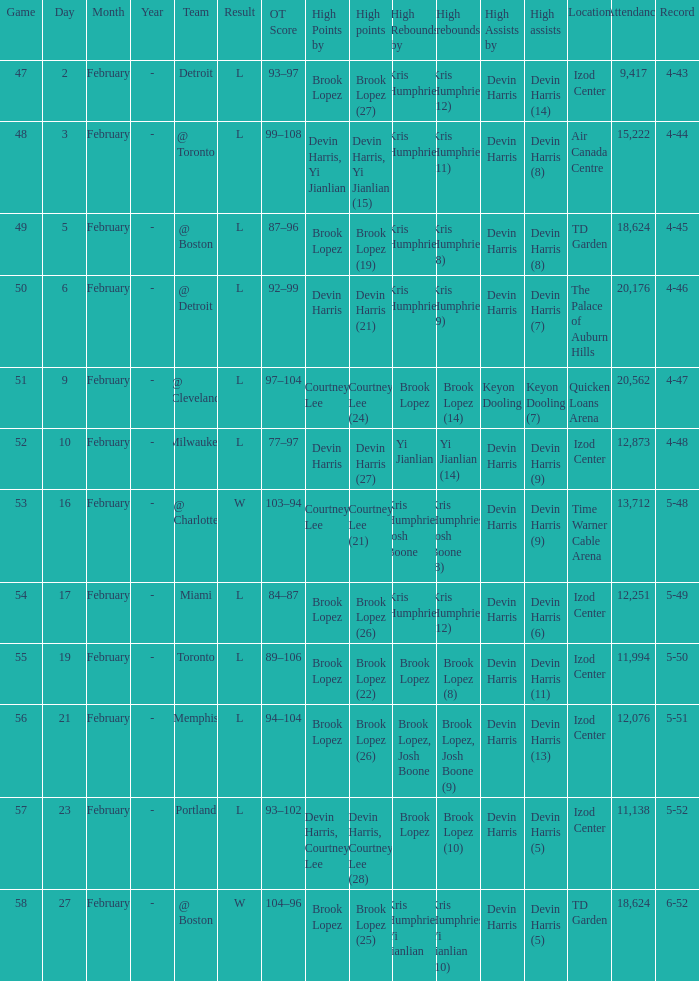What was the result in the game versus memphis? 5-51. 